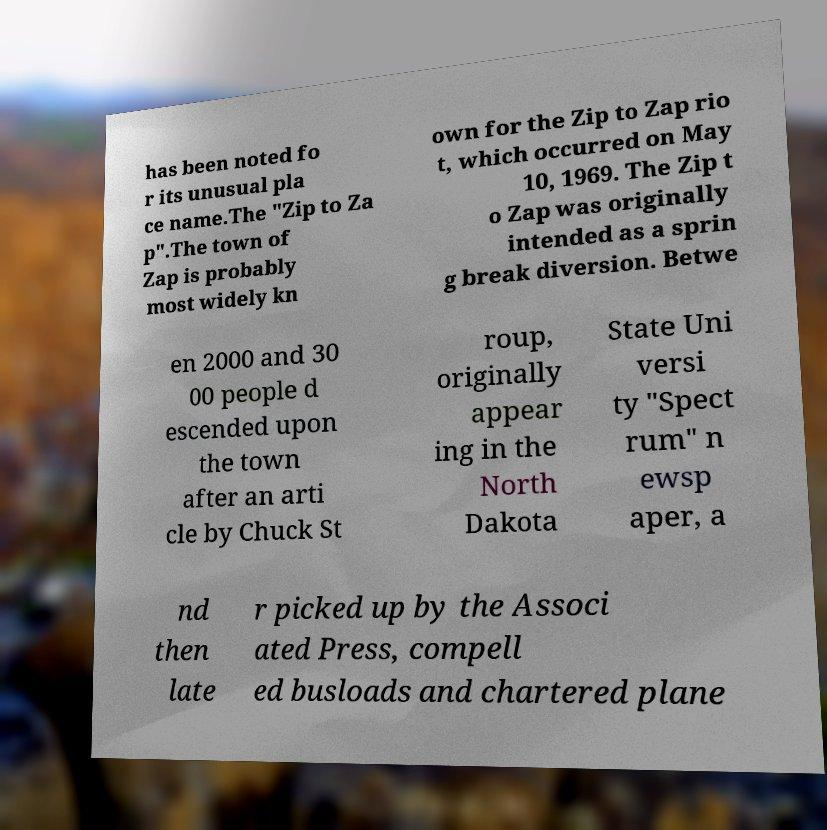What messages or text are displayed in this image? I need them in a readable, typed format. has been noted fo r its unusual pla ce name.The "Zip to Za p".The town of Zap is probably most widely kn own for the Zip to Zap rio t, which occurred on May 10, 1969. The Zip t o Zap was originally intended as a sprin g break diversion. Betwe en 2000 and 30 00 people d escended upon the town after an arti cle by Chuck St roup, originally appear ing in the North Dakota State Uni versi ty "Spect rum" n ewsp aper, a nd then late r picked up by the Associ ated Press, compell ed busloads and chartered plane 